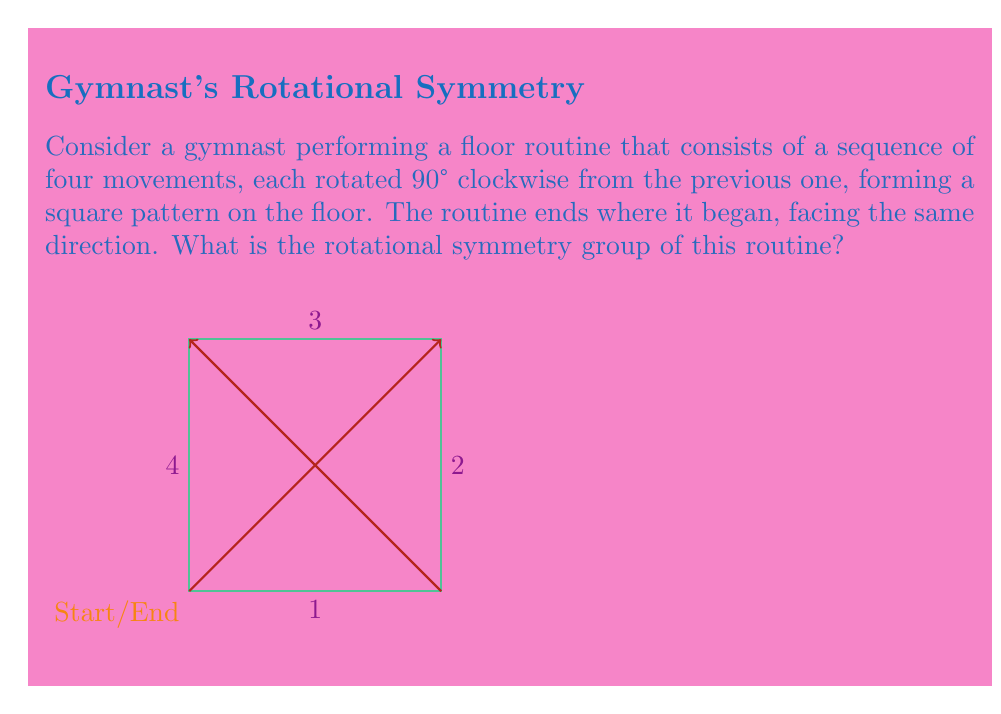Solve this math problem. To determine the rotational symmetry group of the gymnast's floor routine, we need to analyze the symmetries of the pattern formed by the routine:

1) First, let's identify the rotations that leave the pattern unchanged:
   - 0° rotation (identity)
   - 90° clockwise rotation
   - 180° rotation
   - 270° clockwise rotation (or 90° counterclockwise)

2) These rotations form a group under composition. Let's call them:
   $e$ (identity), $r$ (90° clockwise), $r^2$ (180°), $r^3$ (270° clockwise)

3) The group operation table would be:
   $$\begin{array}{c|cccc}
   \circ & e & r & r^2 & r^3 \\
   \hline
   e & e & r & r^2 & r^3 \\
   r & r & r^2 & r^3 & e \\
   r^2 & r^2 & r^3 & e & r \\
   r^3 & r^3 & e & r & r^2
   \end{array}$$

4) This group has four elements and is cyclic, generated by $r$.

5) The structure of this group is isomorphic to the cyclic group of order 4, denoted as $C_4$ or $\mathbb{Z}_4$.

Therefore, the rotational symmetry group of the gymnast's floor routine is isomorphic to $C_4$ or $\mathbb{Z}_4$.
Answer: $C_4$ or $\mathbb{Z}_4$ 